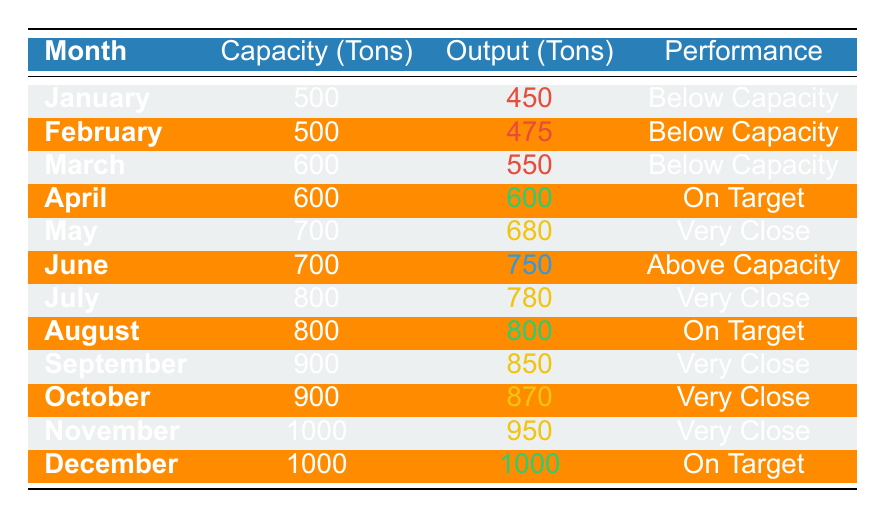What was the actual output in June? The actual output in June is directly indicated in the table under the "Output (Tons)" column for June, which shows 750 tons.
Answer: 750 tons Which month had the highest actual output? By surveying the "Output (Tons)" column, December has the highest output of 1000 tons.
Answer: December How much below capacity was the output in January? The monthly production capacity for January is 500 tons and the actual output is 450 tons. To find the difference: 500 - 450 = 50 tons below capacity.
Answer: 50 tons What is the average actual output for the months from January to April? Adding the actual outputs for these months: 450 + 475 + 550 + 600 = 2075 tons. There are 4 months, so the average is 2075 / 4 = 518.75 tons.
Answer: 518.75 tons Did output ever exceed capacity in 2022? The table indicates that June shows an output of 750 tons against a capacity of 700 tons, meaning the output did exceed the capacity that month.
Answer: Yes Which months were exactly on target? According to the table, the months marked "On Target" are April, August, and December, where the actual output equals the production capacity.
Answer: April, August, December What is the total output for the second half of the year (July to December)? The outputs for the second half of the year are: July (780), August (800), September (850), October (870), November (950), December (1000). The total output is 780 + 800 + 850 + 870 + 950 + 1000 = 4250 tons.
Answer: 4250 tons In which month was the output closest to capacity without exceeding it? The months of May, July, September, October, and November all have outputs very close to capacity, but November at 950 tons is the closest without exceeding.
Answer: November What is the difference in capacity between the highest and lowest months? The highest capacity is 1000 tons in December and the lowest is 500 tons in January. The difference is 1000 - 500 = 500 tons.
Answer: 500 tons How many months had an output below capacity? Referring to the "Performance" column, there are 3 months (January, February, March) where the output was below capacity.
Answer: 3 months 